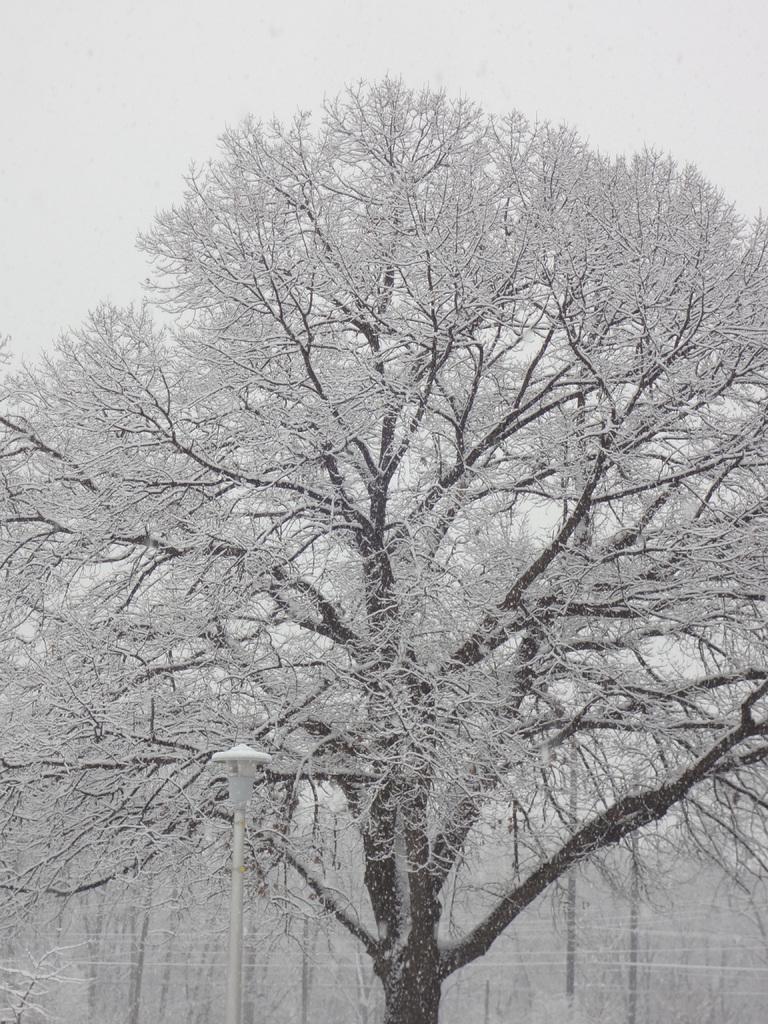Describe this image in one or two sentences. This image consists of a tree. There is snow on the tree. It has branches. 